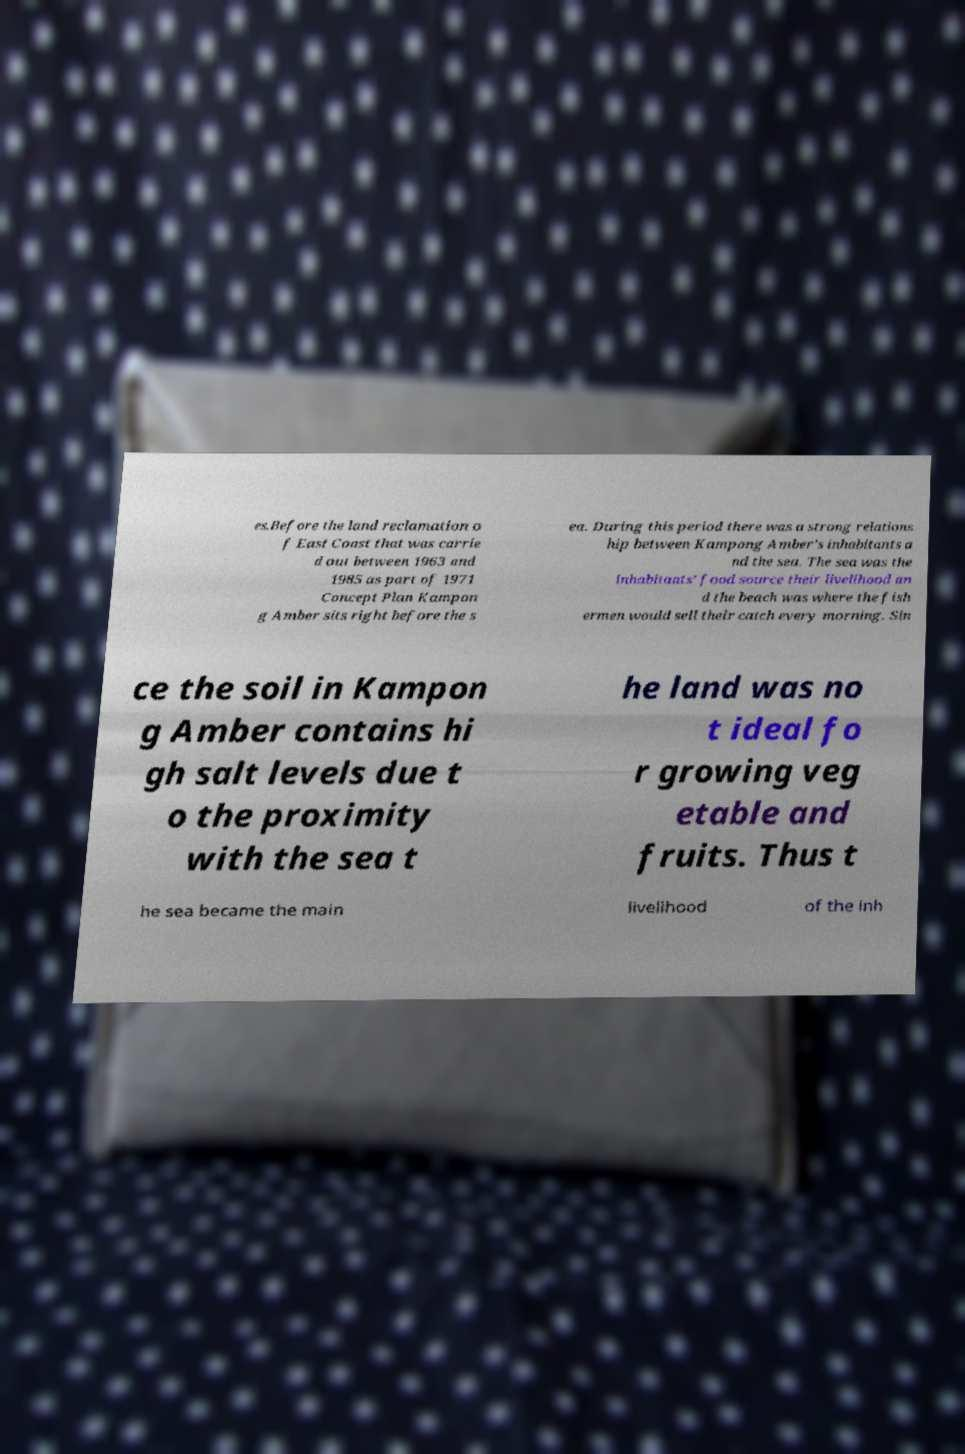For documentation purposes, I need the text within this image transcribed. Could you provide that? es.Before the land reclamation o f East Coast that was carrie d out between 1963 and 1985 as part of 1971 Concept Plan Kampon g Amber sits right before the s ea. During this period there was a strong relations hip between Kampong Amber’s inhabitants a nd the sea. The sea was the inhabitants’ food source their livelihood an d the beach was where the fish ermen would sell their catch every morning. Sin ce the soil in Kampon g Amber contains hi gh salt levels due t o the proximity with the sea t he land was no t ideal fo r growing veg etable and fruits. Thus t he sea became the main livelihood of the inh 